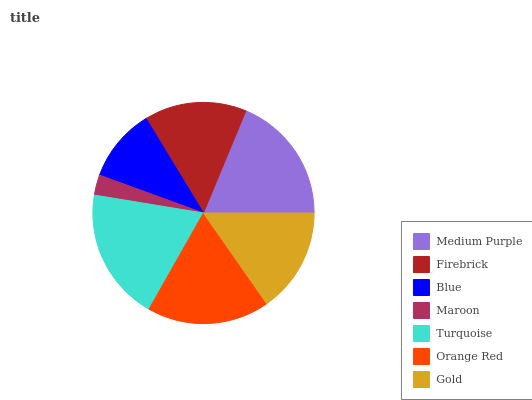Is Maroon the minimum?
Answer yes or no. Yes. Is Turquoise the maximum?
Answer yes or no. Yes. Is Firebrick the minimum?
Answer yes or no. No. Is Firebrick the maximum?
Answer yes or no. No. Is Medium Purple greater than Firebrick?
Answer yes or no. Yes. Is Firebrick less than Medium Purple?
Answer yes or no. Yes. Is Firebrick greater than Medium Purple?
Answer yes or no. No. Is Medium Purple less than Firebrick?
Answer yes or no. No. Is Gold the high median?
Answer yes or no. Yes. Is Gold the low median?
Answer yes or no. Yes. Is Blue the high median?
Answer yes or no. No. Is Maroon the low median?
Answer yes or no. No. 